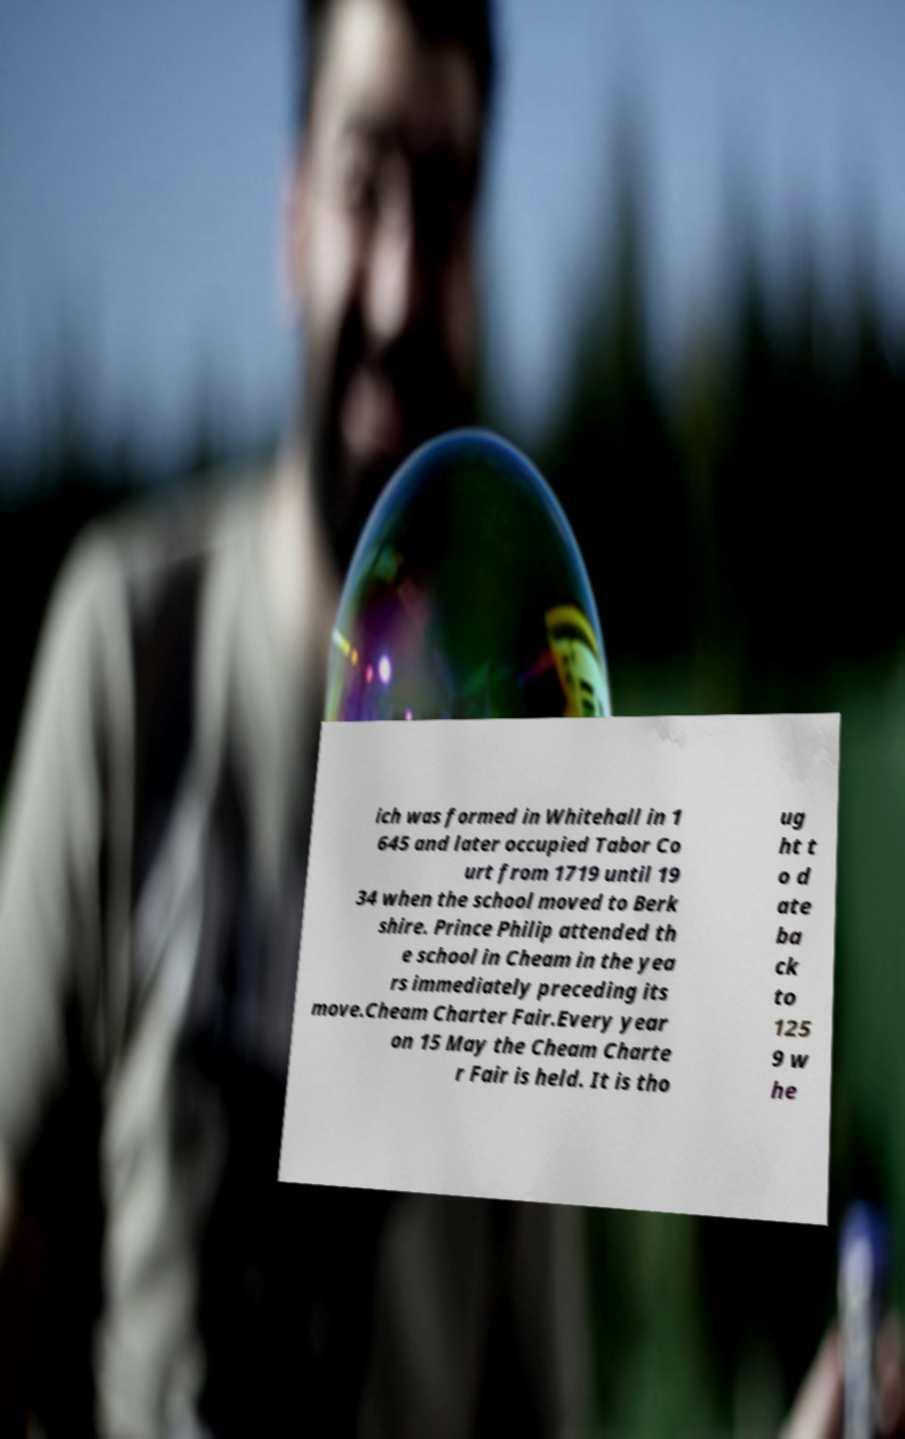What messages or text are displayed in this image? I need them in a readable, typed format. ich was formed in Whitehall in 1 645 and later occupied Tabor Co urt from 1719 until 19 34 when the school moved to Berk shire. Prince Philip attended th e school in Cheam in the yea rs immediately preceding its move.Cheam Charter Fair.Every year on 15 May the Cheam Charte r Fair is held. It is tho ug ht t o d ate ba ck to 125 9 w he 